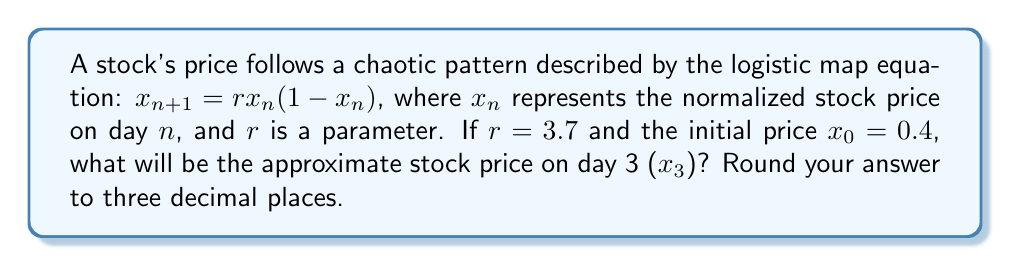Show me your answer to this math problem. Let's approach this step-by-step:

1) We start with the logistic map equation: $x_{n+1} = rx_n(1-x_n)$

2) We're given that $r = 3.7$ and $x_0 = 0.4$

3) Let's calculate $x_1$:
   $x_1 = 3.7 * 0.4 * (1-0.4)$
   $x_1 = 3.7 * 0.4 * 0.6$
   $x_1 = 0.888$

4) Now let's calculate $x_2$:
   $x_2 = 3.7 * 0.888 * (1-0.888)$
   $x_2 = 3.7 * 0.888 * 0.112$
   $x_2 = 0.368$

5) Finally, let's calculate $x_3$:
   $x_3 = 3.7 * 0.368 * (1-0.368)$
   $x_3 = 3.7 * 0.368 * 0.632$
   $x_3 = 0.861$

6) Rounding to three decimal places, we get 0.861.

This demonstrates how chaotic systems, like stock prices in this simplified model, can be very sensitive to initial conditions and quickly become difficult to predict over time.
Answer: 0.861 